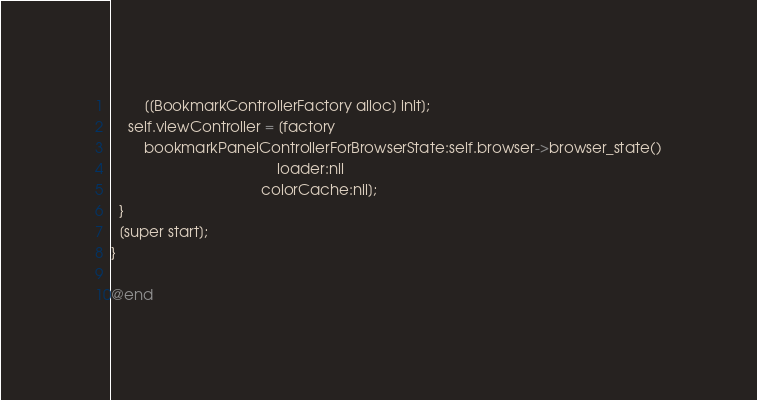Convert code to text. <code><loc_0><loc_0><loc_500><loc_500><_ObjectiveC_>        [[BookmarkControllerFactory alloc] init];
    self.viewController = [factory
        bookmarkPanelControllerForBrowserState:self.browser->browser_state()
                                        loader:nil
                                    colorCache:nil];
  }
  [super start];
}

@end
</code> 